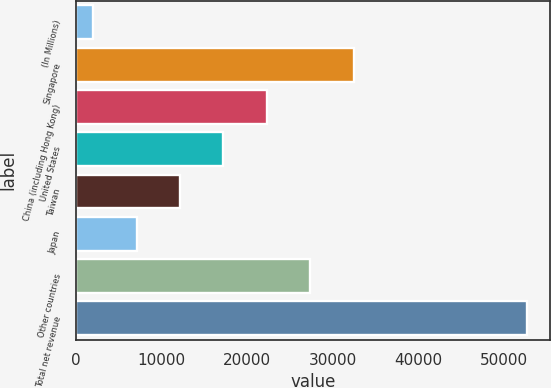<chart> <loc_0><loc_0><loc_500><loc_500><bar_chart><fcel>(In Millions)<fcel>Singapore<fcel>China (including Hong Kong)<fcel>United States<fcel>Taiwan<fcel>Japan<fcel>Other countries<fcel>Total net revenue<nl><fcel>2013<fcel>32430<fcel>22291<fcel>17221.5<fcel>12152<fcel>7082.5<fcel>27360.5<fcel>52708<nl></chart> 